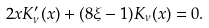Convert formula to latex. <formula><loc_0><loc_0><loc_500><loc_500>2 x K ^ { \prime } _ { \nu } ( x ) + ( 8 \xi - 1 ) K _ { \nu } ( x ) = 0 .</formula> 